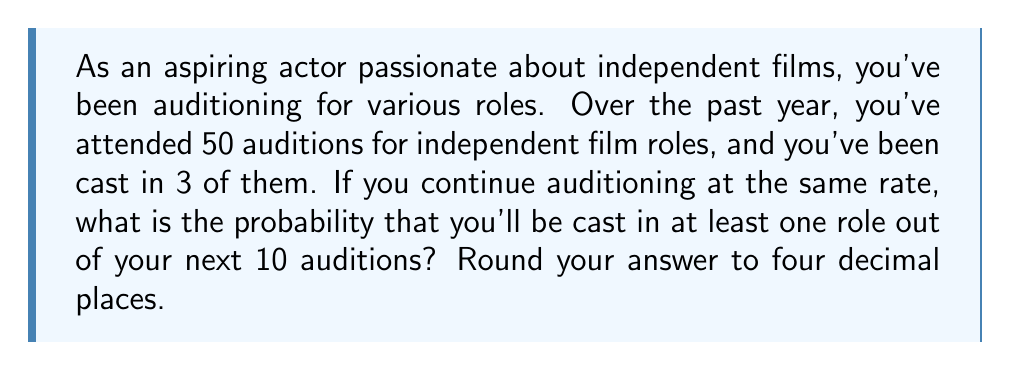Can you solve this math problem? To solve this problem, we'll use the concept of probability and the binomial distribution.

1) First, let's calculate the probability of being cast in a single audition:
   $p = \frac{\text{Number of successful castings}}{\text{Total number of auditions}} = \frac{3}{50} = 0.06$

2) The probability of not being cast in a single audition is:
   $q = 1 - p = 1 - 0.06 = 0.94$

3) We want to find the probability of being cast in at least one role out of 10 auditions. This is equivalent to 1 minus the probability of not being cast in any of the 10 auditions.

4) The probability of not being cast in any of the 10 auditions is:
   $P(\text{no castings}) = q^{10} = 0.94^{10} \approx 0.5386$

5) Therefore, the probability of being cast in at least one role is:
   $P(\text{at least one casting}) = 1 - P(\text{no castings}) = 1 - 0.5386 = 0.4614$

6) Rounding to four decimal places:
   $0.4614 \approx 0.4614$

This means you have approximately a 46.14% chance of being cast in at least one role in your next 10 auditions.
Answer: 0.4614 